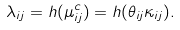<formula> <loc_0><loc_0><loc_500><loc_500>\lambda _ { i j } = h ( \mu ^ { c } _ { i j } ) = h ( \theta _ { i j } \kappa _ { i j } ) .</formula> 